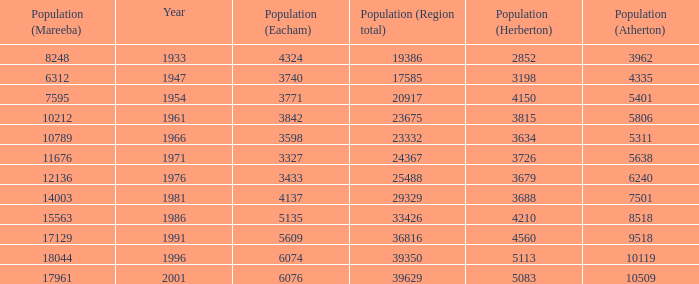What was the smallest population figure for Mareeba? 6312.0. 